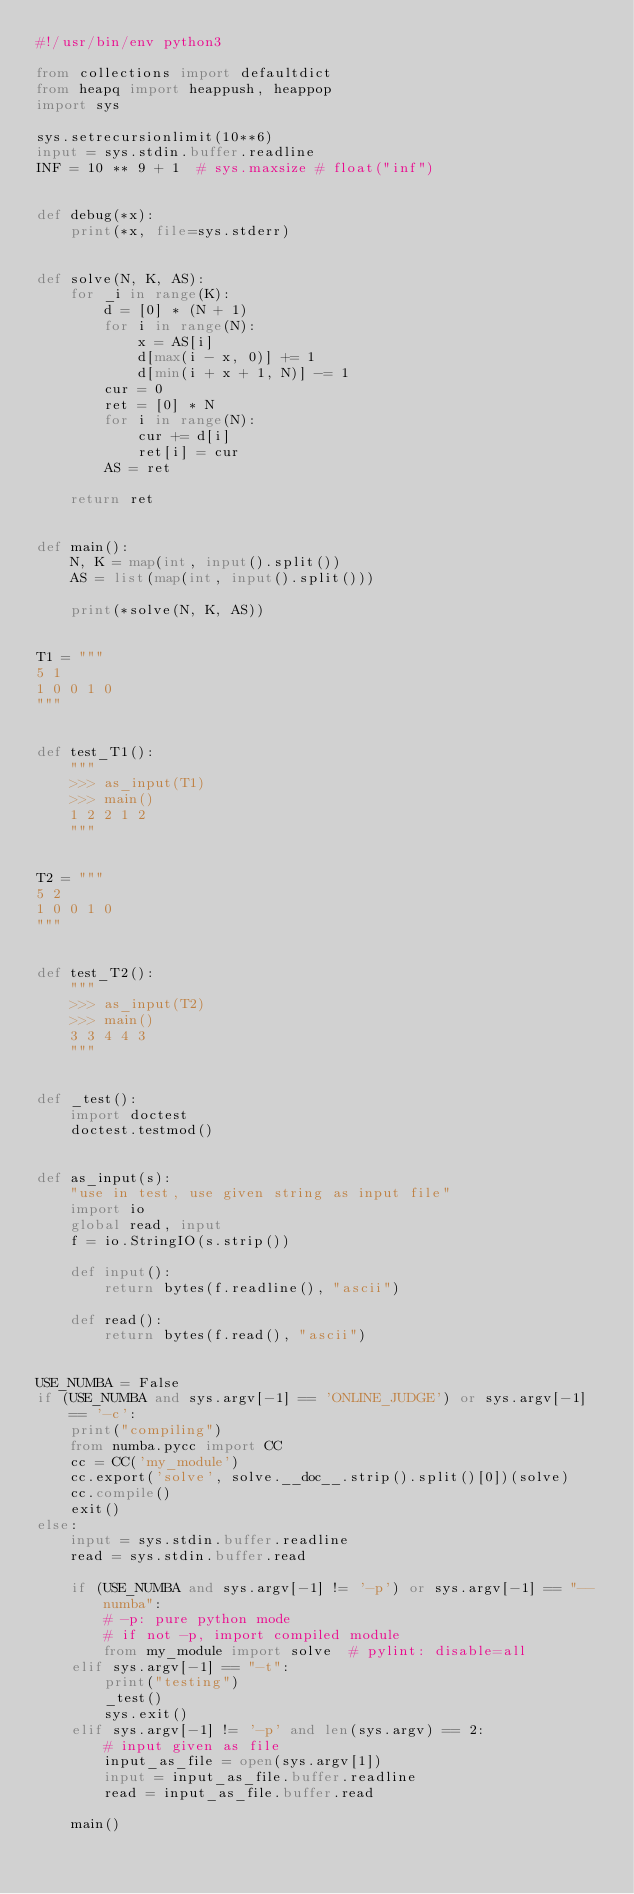<code> <loc_0><loc_0><loc_500><loc_500><_Python_>#!/usr/bin/env python3

from collections import defaultdict
from heapq import heappush, heappop
import sys

sys.setrecursionlimit(10**6)
input = sys.stdin.buffer.readline
INF = 10 ** 9 + 1  # sys.maxsize # float("inf")


def debug(*x):
    print(*x, file=sys.stderr)


def solve(N, K, AS):
    for _i in range(K):
        d = [0] * (N + 1)
        for i in range(N):
            x = AS[i]
            d[max(i - x, 0)] += 1
            d[min(i + x + 1, N)] -= 1
        cur = 0
        ret = [0] * N
        for i in range(N):
            cur += d[i]
            ret[i] = cur
        AS = ret

    return ret


def main():
    N, K = map(int, input().split())
    AS = list(map(int, input().split()))

    print(*solve(N, K, AS))


T1 = """
5 1
1 0 0 1 0
"""


def test_T1():
    """
    >>> as_input(T1)
    >>> main()
    1 2 2 1 2
    """


T2 = """
5 2
1 0 0 1 0
"""


def test_T2():
    """
    >>> as_input(T2)
    >>> main()
    3 3 4 4 3
    """


def _test():
    import doctest
    doctest.testmod()


def as_input(s):
    "use in test, use given string as input file"
    import io
    global read, input
    f = io.StringIO(s.strip())

    def input():
        return bytes(f.readline(), "ascii")

    def read():
        return bytes(f.read(), "ascii")


USE_NUMBA = False
if (USE_NUMBA and sys.argv[-1] == 'ONLINE_JUDGE') or sys.argv[-1] == '-c':
    print("compiling")
    from numba.pycc import CC
    cc = CC('my_module')
    cc.export('solve', solve.__doc__.strip().split()[0])(solve)
    cc.compile()
    exit()
else:
    input = sys.stdin.buffer.readline
    read = sys.stdin.buffer.read

    if (USE_NUMBA and sys.argv[-1] != '-p') or sys.argv[-1] == "--numba":
        # -p: pure python mode
        # if not -p, import compiled module
        from my_module import solve  # pylint: disable=all
    elif sys.argv[-1] == "-t":
        print("testing")
        _test()
        sys.exit()
    elif sys.argv[-1] != '-p' and len(sys.argv) == 2:
        # input given as file
        input_as_file = open(sys.argv[1])
        input = input_as_file.buffer.readline
        read = input_as_file.buffer.read

    main()
</code> 